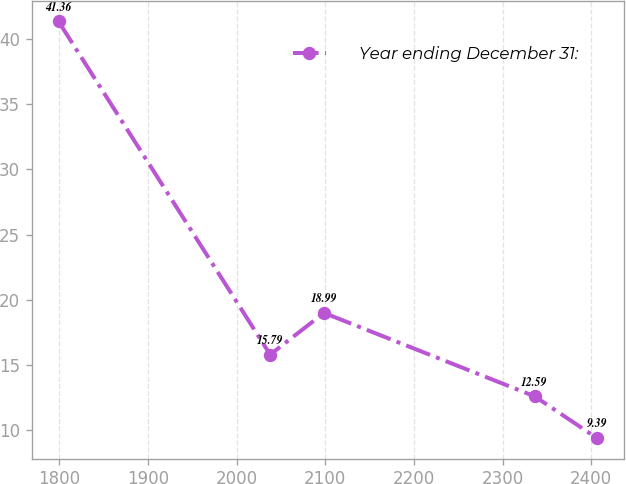Convert chart. <chart><loc_0><loc_0><loc_500><loc_500><line_chart><ecel><fcel>Year ending December 31:<nl><fcel>1799.32<fcel>41.36<nl><fcel>2037.96<fcel>15.79<nl><fcel>2098.65<fcel>18.99<nl><fcel>2336.08<fcel>12.59<nl><fcel>2406.22<fcel>9.39<nl></chart> 